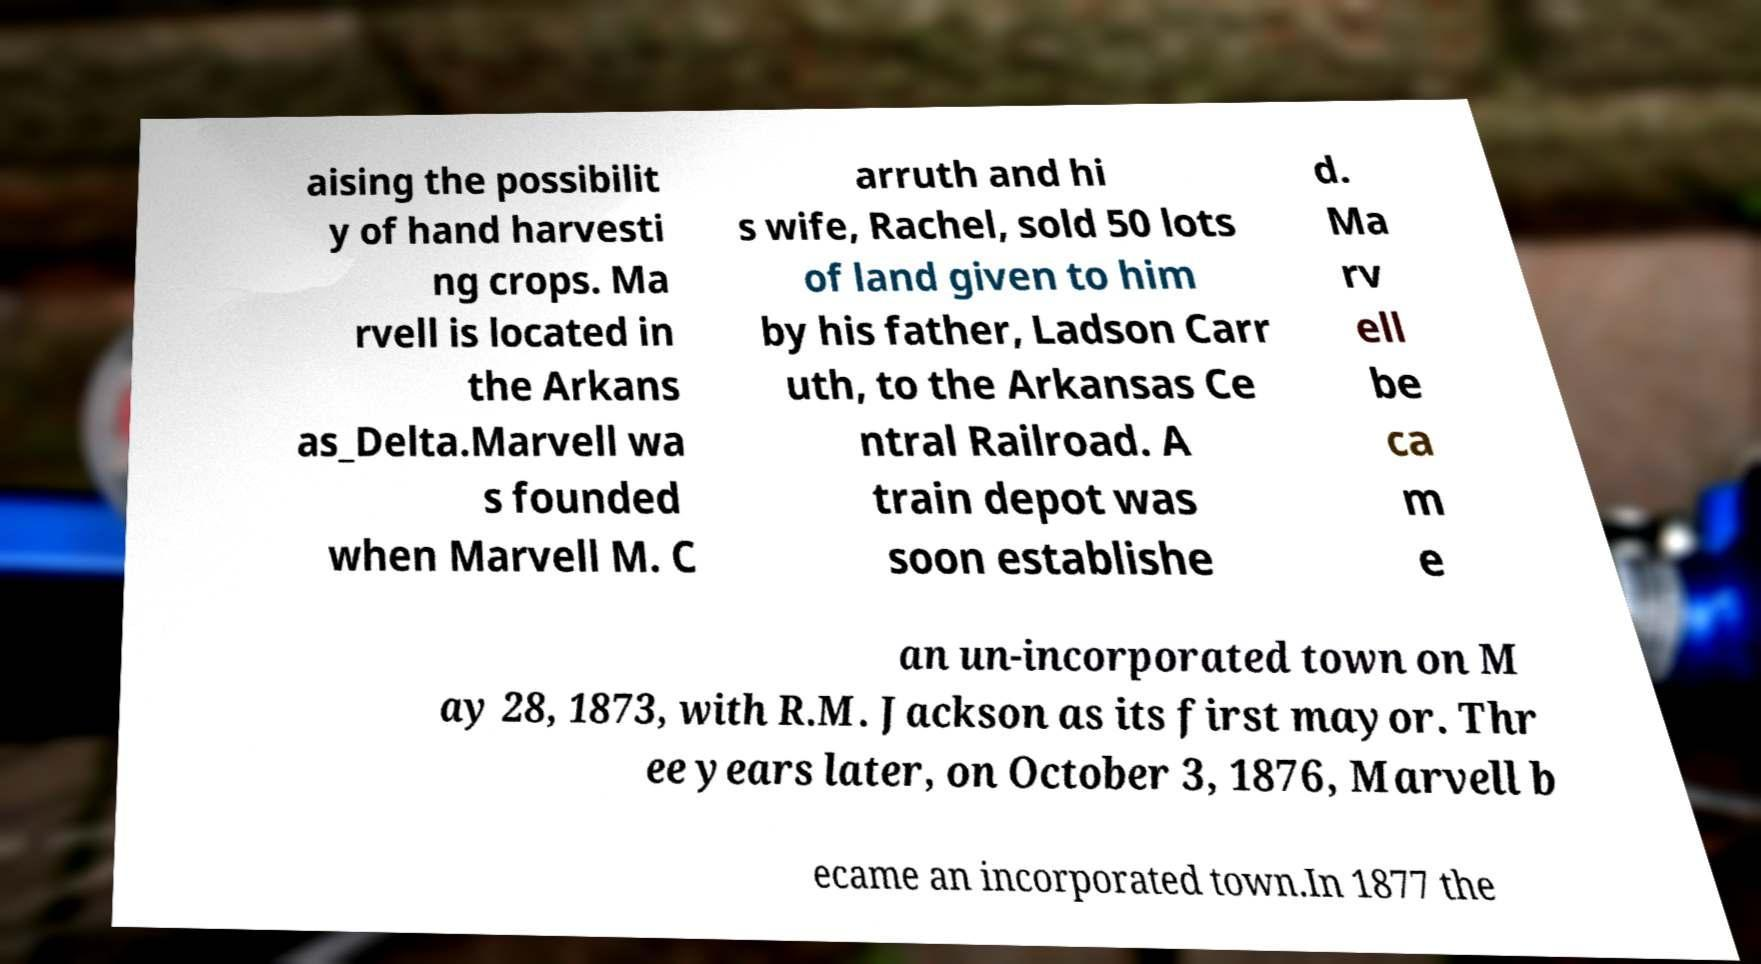Can you read and provide the text displayed in the image?This photo seems to have some interesting text. Can you extract and type it out for me? aising the possibilit y of hand harvesti ng crops. Ma rvell is located in the Arkans as_Delta.Marvell wa s founded when Marvell M. C arruth and hi s wife, Rachel, sold 50 lots of land given to him by his father, Ladson Carr uth, to the Arkansas Ce ntral Railroad. A train depot was soon establishe d. Ma rv ell be ca m e an un-incorporated town on M ay 28, 1873, with R.M. Jackson as its first mayor. Thr ee years later, on October 3, 1876, Marvell b ecame an incorporated town.In 1877 the 